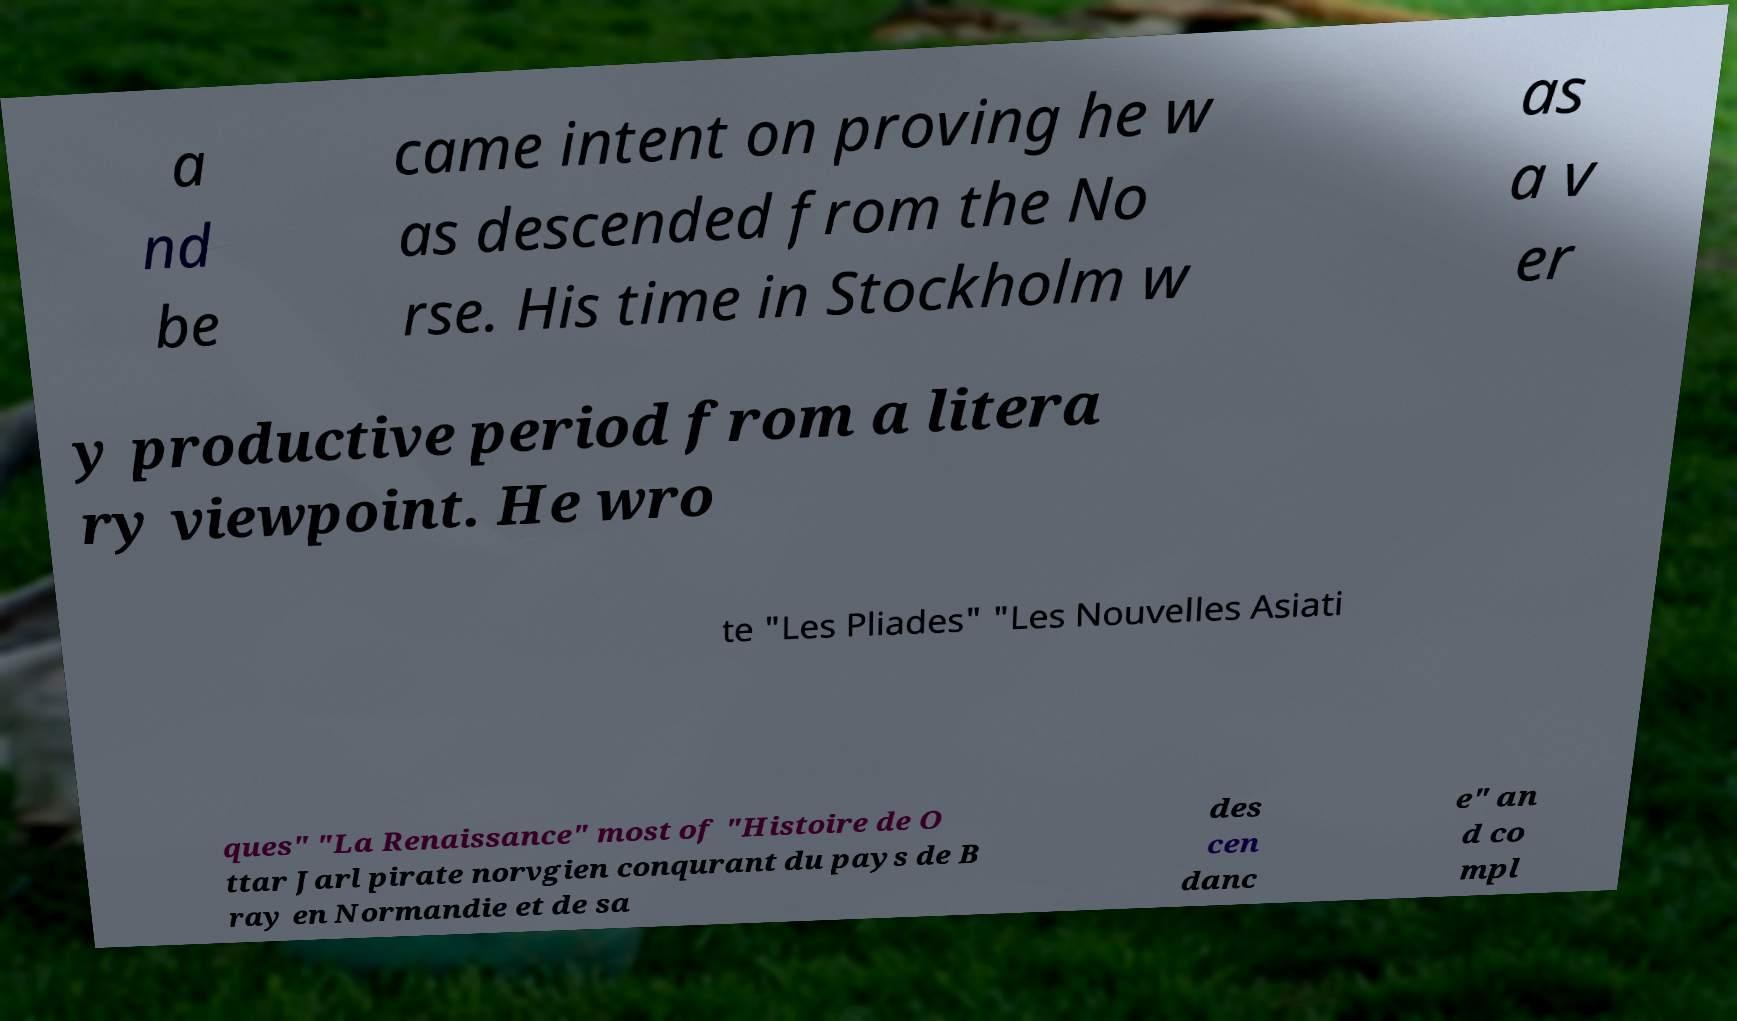What messages or text are displayed in this image? I need them in a readable, typed format. a nd be came intent on proving he w as descended from the No rse. His time in Stockholm w as a v er y productive period from a litera ry viewpoint. He wro te "Les Pliades" "Les Nouvelles Asiati ques" "La Renaissance" most of "Histoire de O ttar Jarl pirate norvgien conqurant du pays de B ray en Normandie et de sa des cen danc e" an d co mpl 